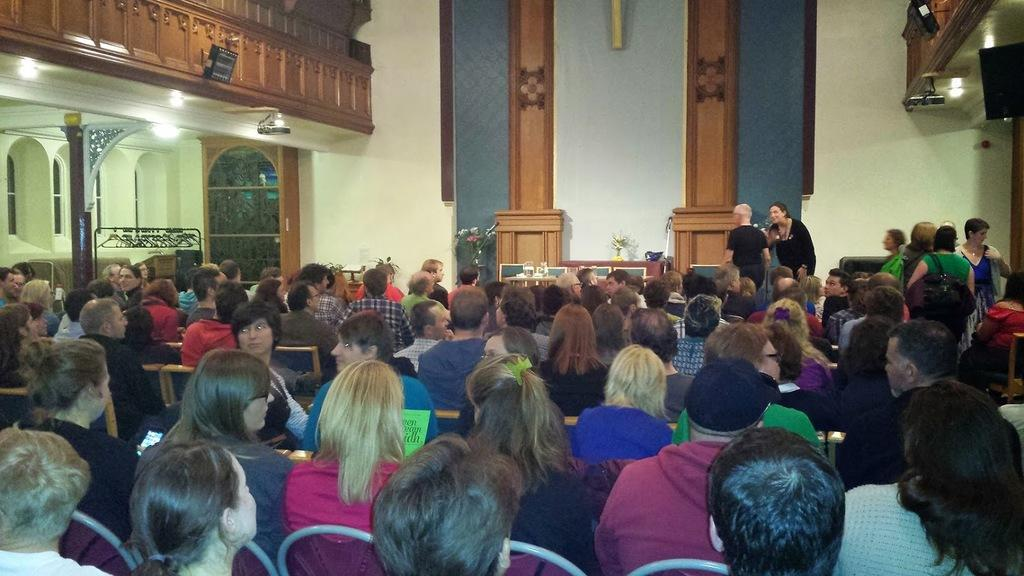How many people are in the image? There is a group of people in the image, but the exact number is not specified. What are the people in the image doing? Some people are seated, while others are standing. What objects are in front of the group? There are microphones and a speaker in front of the group. What can be seen in the image that provides illumination? Lights are visible in the image. What type of decorative items are present in the image? Flower vases are present in the image. What type of worm can be seen crawling on the speaker in the image? There is no worm present in the image; it only features a group of people, microphones, a speaker, lights, and flower vases. 